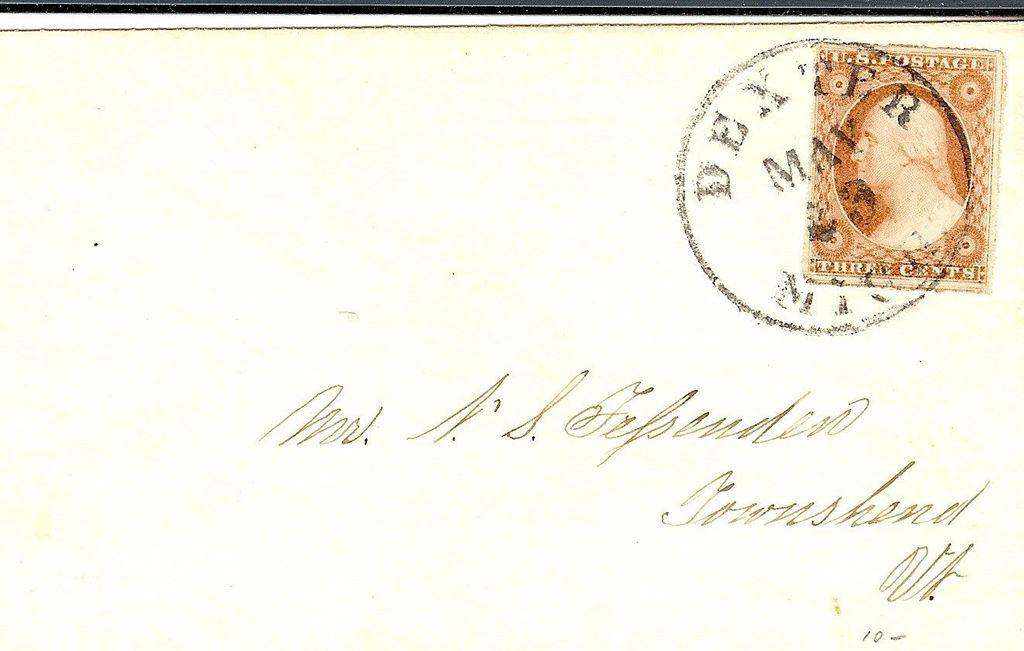<image>
Render a clear and concise summary of the photo. A dexter post mark is on a beige envelope with a U.S. postage 3 cent stamp on it. 